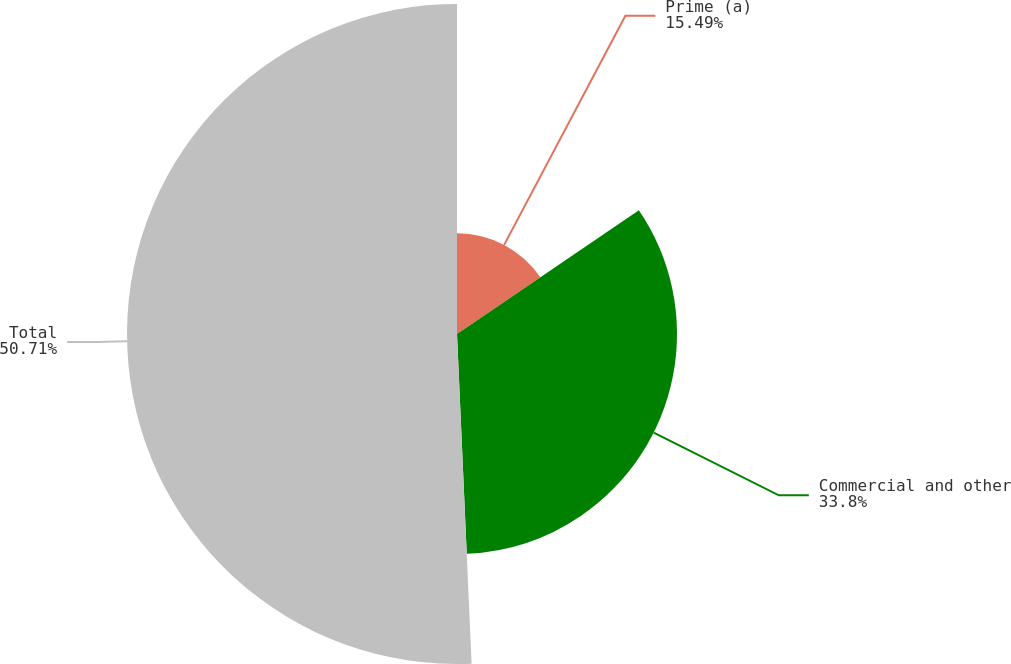<chart> <loc_0><loc_0><loc_500><loc_500><pie_chart><fcel>Prime (a)<fcel>Commercial and other<fcel>Total<nl><fcel>15.49%<fcel>33.8%<fcel>50.7%<nl></chart> 